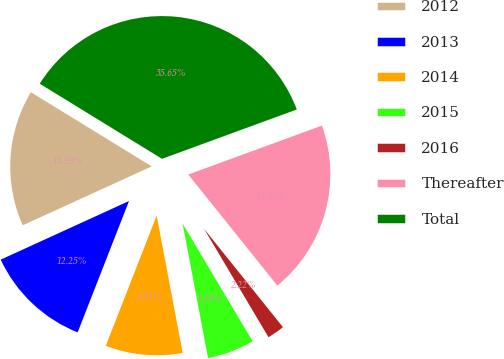Convert chart to OTSL. <chart><loc_0><loc_0><loc_500><loc_500><pie_chart><fcel>2012<fcel>2013<fcel>2014<fcel>2015<fcel>2016<fcel>Thereafter<fcel>Total<nl><fcel>15.59%<fcel>12.25%<fcel>8.91%<fcel>5.56%<fcel>2.22%<fcel>19.83%<fcel>35.65%<nl></chart> 